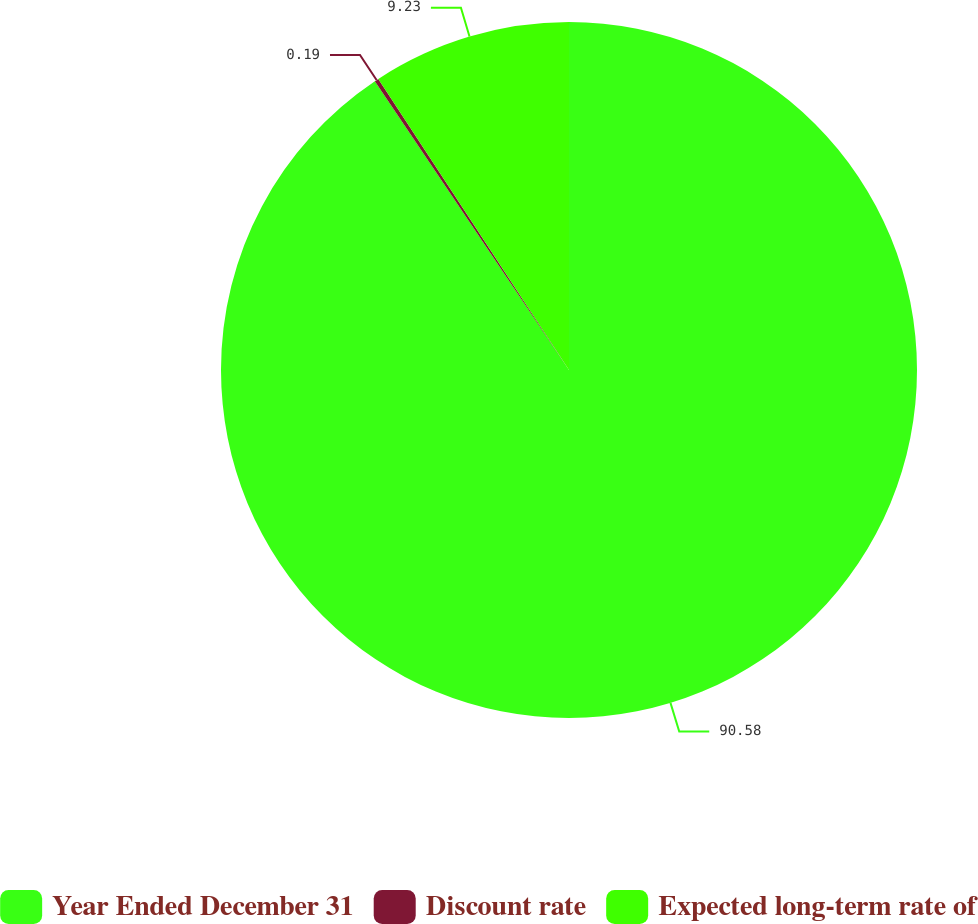<chart> <loc_0><loc_0><loc_500><loc_500><pie_chart><fcel>Year Ended December 31<fcel>Discount rate<fcel>Expected long-term rate of<nl><fcel>90.58%<fcel>0.19%<fcel>9.23%<nl></chart> 